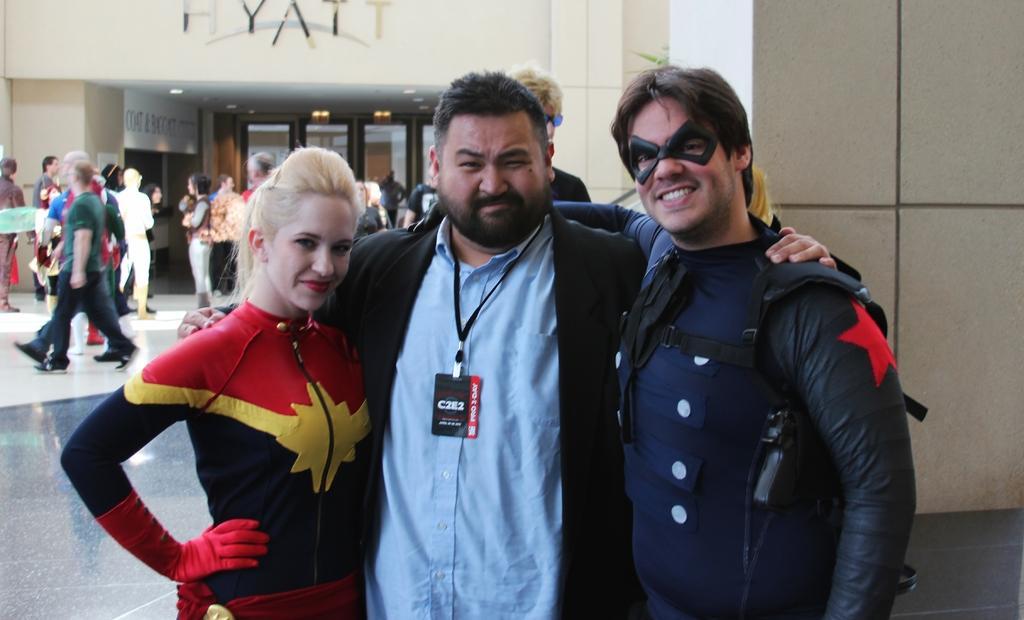Please provide a concise description of this image. In this picture, we see two men and a woman are standing. They are smiling and they are posing for the photo. Behind them, we see two people are standing. On the left side, we see many people are standing. On the right side, we see a wall. In the background, we see a building which has the glass doors. On top of the building, we see a white color board with some text written on it. This picture might be clicked in the mall. 